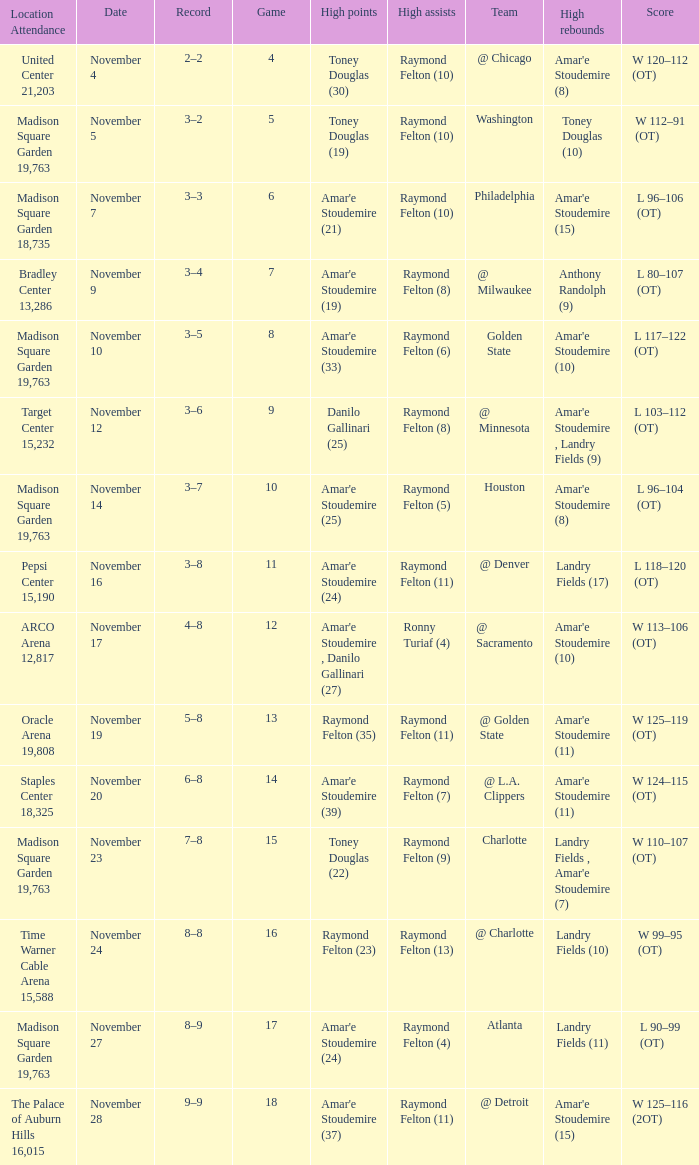What game number is the Washington team. 1.0. 